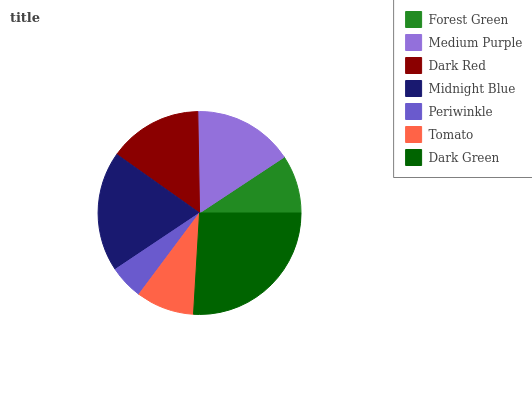Is Periwinkle the minimum?
Answer yes or no. Yes. Is Dark Green the maximum?
Answer yes or no. Yes. Is Medium Purple the minimum?
Answer yes or no. No. Is Medium Purple the maximum?
Answer yes or no. No. Is Medium Purple greater than Forest Green?
Answer yes or no. Yes. Is Forest Green less than Medium Purple?
Answer yes or no. Yes. Is Forest Green greater than Medium Purple?
Answer yes or no. No. Is Medium Purple less than Forest Green?
Answer yes or no. No. Is Dark Red the high median?
Answer yes or no. Yes. Is Dark Red the low median?
Answer yes or no. Yes. Is Medium Purple the high median?
Answer yes or no. No. Is Midnight Blue the low median?
Answer yes or no. No. 